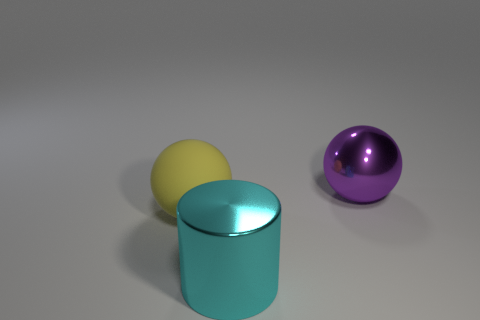There is a rubber sphere left of the big cyan cylinder on the right side of the ball to the left of the large metallic ball; what color is it?
Your answer should be compact. Yellow. Are there any green blocks?
Offer a very short reply. No. What number of other objects are there of the same size as the purple thing?
Give a very brief answer. 2. What number of objects are either purple spheres or big yellow rubber spheres?
Offer a very short reply. 2. Is the cylinder made of the same material as the large object that is left of the large cylinder?
Your answer should be compact. No. The large shiny object that is in front of the big sphere behind the large yellow matte object is what shape?
Keep it short and to the point. Cylinder. There is a big thing that is to the right of the rubber sphere and left of the large shiny ball; what shape is it?
Offer a very short reply. Cylinder. How many things are yellow rubber blocks or metallic objects that are behind the big yellow sphere?
Offer a very short reply. 1. There is another big purple object that is the same shape as the rubber thing; what material is it?
Keep it short and to the point. Metal. Are there any other things that are made of the same material as the yellow sphere?
Offer a terse response. No. 